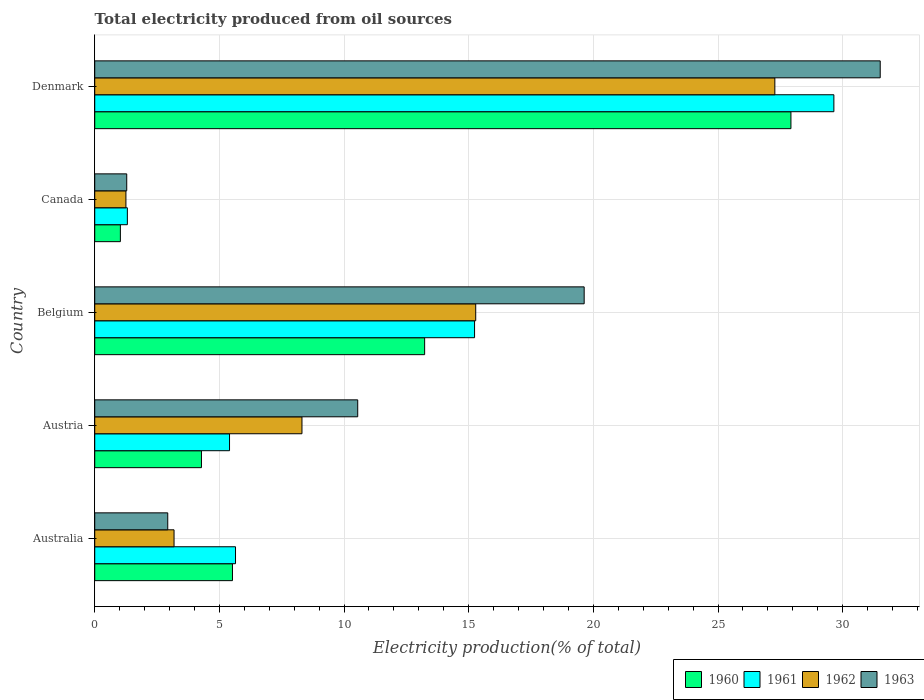How many different coloured bars are there?
Keep it short and to the point. 4. Are the number of bars on each tick of the Y-axis equal?
Provide a short and direct response. Yes. How many bars are there on the 3rd tick from the bottom?
Make the answer very short. 4. In how many cases, is the number of bars for a given country not equal to the number of legend labels?
Give a very brief answer. 0. What is the total electricity produced in 1961 in Canada?
Offer a very short reply. 1.31. Across all countries, what is the maximum total electricity produced in 1960?
Keep it short and to the point. 27.92. Across all countries, what is the minimum total electricity produced in 1962?
Provide a succinct answer. 1.25. What is the total total electricity produced in 1961 in the graph?
Offer a terse response. 57.24. What is the difference between the total electricity produced in 1963 in Canada and that in Denmark?
Offer a very short reply. -30.22. What is the difference between the total electricity produced in 1960 in Austria and the total electricity produced in 1963 in Belgium?
Offer a very short reply. -15.35. What is the average total electricity produced in 1961 per country?
Ensure brevity in your answer.  11.45. What is the difference between the total electricity produced in 1962 and total electricity produced in 1963 in Denmark?
Offer a very short reply. -4.23. In how many countries, is the total electricity produced in 1963 greater than 11 %?
Provide a short and direct response. 2. What is the ratio of the total electricity produced in 1961 in Belgium to that in Denmark?
Offer a terse response. 0.51. Is the total electricity produced in 1961 in Belgium less than that in Canada?
Provide a short and direct response. No. What is the difference between the highest and the second highest total electricity produced in 1960?
Your response must be concise. 14.69. What is the difference between the highest and the lowest total electricity produced in 1961?
Give a very brief answer. 28.34. Is it the case that in every country, the sum of the total electricity produced in 1963 and total electricity produced in 1961 is greater than the sum of total electricity produced in 1962 and total electricity produced in 1960?
Make the answer very short. No. What does the 2nd bar from the top in Canada represents?
Keep it short and to the point. 1962. Are all the bars in the graph horizontal?
Ensure brevity in your answer.  Yes. Does the graph contain any zero values?
Offer a very short reply. No. What is the title of the graph?
Give a very brief answer. Total electricity produced from oil sources. Does "2006" appear as one of the legend labels in the graph?
Your answer should be compact. No. What is the label or title of the X-axis?
Keep it short and to the point. Electricity production(% of total). What is the label or title of the Y-axis?
Offer a very short reply. Country. What is the Electricity production(% of total) of 1960 in Australia?
Your answer should be very brief. 5.52. What is the Electricity production(% of total) in 1961 in Australia?
Provide a short and direct response. 5.65. What is the Electricity production(% of total) in 1962 in Australia?
Your answer should be very brief. 3.18. What is the Electricity production(% of total) in 1963 in Australia?
Your answer should be very brief. 2.93. What is the Electricity production(% of total) in 1960 in Austria?
Offer a very short reply. 4.28. What is the Electricity production(% of total) of 1961 in Austria?
Your response must be concise. 5.41. What is the Electricity production(% of total) of 1962 in Austria?
Your answer should be compact. 8.31. What is the Electricity production(% of total) in 1963 in Austria?
Give a very brief answer. 10.55. What is the Electricity production(% of total) of 1960 in Belgium?
Keep it short and to the point. 13.23. What is the Electricity production(% of total) in 1961 in Belgium?
Your answer should be compact. 15.23. What is the Electricity production(% of total) of 1962 in Belgium?
Provide a succinct answer. 15.28. What is the Electricity production(% of total) of 1963 in Belgium?
Make the answer very short. 19.63. What is the Electricity production(% of total) in 1960 in Canada?
Offer a very short reply. 1.03. What is the Electricity production(% of total) of 1961 in Canada?
Your answer should be compact. 1.31. What is the Electricity production(% of total) of 1962 in Canada?
Make the answer very short. 1.25. What is the Electricity production(% of total) in 1963 in Canada?
Your response must be concise. 1.28. What is the Electricity production(% of total) in 1960 in Denmark?
Provide a succinct answer. 27.92. What is the Electricity production(% of total) in 1961 in Denmark?
Your answer should be very brief. 29.65. What is the Electricity production(% of total) of 1962 in Denmark?
Provide a short and direct response. 27.28. What is the Electricity production(% of total) of 1963 in Denmark?
Your response must be concise. 31.51. Across all countries, what is the maximum Electricity production(% of total) in 1960?
Keep it short and to the point. 27.92. Across all countries, what is the maximum Electricity production(% of total) in 1961?
Provide a succinct answer. 29.65. Across all countries, what is the maximum Electricity production(% of total) of 1962?
Offer a terse response. 27.28. Across all countries, what is the maximum Electricity production(% of total) in 1963?
Provide a short and direct response. 31.51. Across all countries, what is the minimum Electricity production(% of total) of 1960?
Your answer should be compact. 1.03. Across all countries, what is the minimum Electricity production(% of total) of 1961?
Your response must be concise. 1.31. Across all countries, what is the minimum Electricity production(% of total) of 1962?
Your answer should be compact. 1.25. Across all countries, what is the minimum Electricity production(% of total) in 1963?
Make the answer very short. 1.28. What is the total Electricity production(% of total) in 1960 in the graph?
Give a very brief answer. 51.99. What is the total Electricity production(% of total) of 1961 in the graph?
Provide a succinct answer. 57.24. What is the total Electricity production(% of total) of 1962 in the graph?
Your answer should be compact. 55.3. What is the total Electricity production(% of total) of 1963 in the graph?
Keep it short and to the point. 65.9. What is the difference between the Electricity production(% of total) in 1960 in Australia and that in Austria?
Ensure brevity in your answer.  1.24. What is the difference between the Electricity production(% of total) in 1961 in Australia and that in Austria?
Ensure brevity in your answer.  0.24. What is the difference between the Electricity production(% of total) in 1962 in Australia and that in Austria?
Give a very brief answer. -5.13. What is the difference between the Electricity production(% of total) in 1963 in Australia and that in Austria?
Keep it short and to the point. -7.62. What is the difference between the Electricity production(% of total) of 1960 in Australia and that in Belgium?
Your answer should be very brief. -7.71. What is the difference between the Electricity production(% of total) in 1961 in Australia and that in Belgium?
Provide a succinct answer. -9.59. What is the difference between the Electricity production(% of total) in 1962 in Australia and that in Belgium?
Ensure brevity in your answer.  -12.1. What is the difference between the Electricity production(% of total) of 1963 in Australia and that in Belgium?
Offer a very short reply. -16.7. What is the difference between the Electricity production(% of total) of 1960 in Australia and that in Canada?
Your answer should be very brief. 4.5. What is the difference between the Electricity production(% of total) in 1961 in Australia and that in Canada?
Your answer should be compact. 4.34. What is the difference between the Electricity production(% of total) of 1962 in Australia and that in Canada?
Provide a short and direct response. 1.93. What is the difference between the Electricity production(% of total) in 1963 in Australia and that in Canada?
Give a very brief answer. 1.64. What is the difference between the Electricity production(% of total) of 1960 in Australia and that in Denmark?
Your answer should be compact. -22.4. What is the difference between the Electricity production(% of total) in 1961 in Australia and that in Denmark?
Provide a succinct answer. -24. What is the difference between the Electricity production(% of total) of 1962 in Australia and that in Denmark?
Provide a short and direct response. -24.1. What is the difference between the Electricity production(% of total) of 1963 in Australia and that in Denmark?
Provide a short and direct response. -28.58. What is the difference between the Electricity production(% of total) of 1960 in Austria and that in Belgium?
Ensure brevity in your answer.  -8.95. What is the difference between the Electricity production(% of total) in 1961 in Austria and that in Belgium?
Keep it short and to the point. -9.83. What is the difference between the Electricity production(% of total) of 1962 in Austria and that in Belgium?
Give a very brief answer. -6.97. What is the difference between the Electricity production(% of total) in 1963 in Austria and that in Belgium?
Make the answer very short. -9.08. What is the difference between the Electricity production(% of total) in 1960 in Austria and that in Canada?
Provide a short and direct response. 3.25. What is the difference between the Electricity production(% of total) of 1961 in Austria and that in Canada?
Offer a terse response. 4.1. What is the difference between the Electricity production(% of total) of 1962 in Austria and that in Canada?
Provide a short and direct response. 7.06. What is the difference between the Electricity production(% of total) of 1963 in Austria and that in Canada?
Your response must be concise. 9.26. What is the difference between the Electricity production(% of total) in 1960 in Austria and that in Denmark?
Provide a succinct answer. -23.64. What is the difference between the Electricity production(% of total) in 1961 in Austria and that in Denmark?
Keep it short and to the point. -24.24. What is the difference between the Electricity production(% of total) of 1962 in Austria and that in Denmark?
Your answer should be very brief. -18.97. What is the difference between the Electricity production(% of total) in 1963 in Austria and that in Denmark?
Keep it short and to the point. -20.96. What is the difference between the Electricity production(% of total) in 1960 in Belgium and that in Canada?
Ensure brevity in your answer.  12.2. What is the difference between the Electricity production(% of total) in 1961 in Belgium and that in Canada?
Make the answer very short. 13.93. What is the difference between the Electricity production(% of total) in 1962 in Belgium and that in Canada?
Make the answer very short. 14.03. What is the difference between the Electricity production(% of total) in 1963 in Belgium and that in Canada?
Ensure brevity in your answer.  18.35. What is the difference between the Electricity production(% of total) of 1960 in Belgium and that in Denmark?
Ensure brevity in your answer.  -14.69. What is the difference between the Electricity production(% of total) in 1961 in Belgium and that in Denmark?
Provide a succinct answer. -14.41. What is the difference between the Electricity production(% of total) of 1962 in Belgium and that in Denmark?
Give a very brief answer. -12. What is the difference between the Electricity production(% of total) of 1963 in Belgium and that in Denmark?
Your answer should be very brief. -11.87. What is the difference between the Electricity production(% of total) in 1960 in Canada and that in Denmark?
Provide a short and direct response. -26.9. What is the difference between the Electricity production(% of total) in 1961 in Canada and that in Denmark?
Keep it short and to the point. -28.34. What is the difference between the Electricity production(% of total) of 1962 in Canada and that in Denmark?
Ensure brevity in your answer.  -26.03. What is the difference between the Electricity production(% of total) of 1963 in Canada and that in Denmark?
Your response must be concise. -30.22. What is the difference between the Electricity production(% of total) of 1960 in Australia and the Electricity production(% of total) of 1961 in Austria?
Offer a terse response. 0.12. What is the difference between the Electricity production(% of total) of 1960 in Australia and the Electricity production(% of total) of 1962 in Austria?
Provide a short and direct response. -2.79. What is the difference between the Electricity production(% of total) in 1960 in Australia and the Electricity production(% of total) in 1963 in Austria?
Give a very brief answer. -5.02. What is the difference between the Electricity production(% of total) in 1961 in Australia and the Electricity production(% of total) in 1962 in Austria?
Make the answer very short. -2.67. What is the difference between the Electricity production(% of total) in 1961 in Australia and the Electricity production(% of total) in 1963 in Austria?
Give a very brief answer. -4.9. What is the difference between the Electricity production(% of total) of 1962 in Australia and the Electricity production(% of total) of 1963 in Austria?
Ensure brevity in your answer.  -7.37. What is the difference between the Electricity production(% of total) of 1960 in Australia and the Electricity production(% of total) of 1961 in Belgium?
Make the answer very short. -9.71. What is the difference between the Electricity production(% of total) of 1960 in Australia and the Electricity production(% of total) of 1962 in Belgium?
Provide a short and direct response. -9.76. What is the difference between the Electricity production(% of total) of 1960 in Australia and the Electricity production(% of total) of 1963 in Belgium?
Make the answer very short. -14.11. What is the difference between the Electricity production(% of total) in 1961 in Australia and the Electricity production(% of total) in 1962 in Belgium?
Offer a terse response. -9.63. What is the difference between the Electricity production(% of total) in 1961 in Australia and the Electricity production(% of total) in 1963 in Belgium?
Your response must be concise. -13.98. What is the difference between the Electricity production(% of total) of 1962 in Australia and the Electricity production(% of total) of 1963 in Belgium?
Your response must be concise. -16.45. What is the difference between the Electricity production(% of total) in 1960 in Australia and the Electricity production(% of total) in 1961 in Canada?
Keep it short and to the point. 4.22. What is the difference between the Electricity production(% of total) of 1960 in Australia and the Electricity production(% of total) of 1962 in Canada?
Offer a very short reply. 4.27. What is the difference between the Electricity production(% of total) of 1960 in Australia and the Electricity production(% of total) of 1963 in Canada?
Offer a very short reply. 4.24. What is the difference between the Electricity production(% of total) in 1961 in Australia and the Electricity production(% of total) in 1962 in Canada?
Your response must be concise. 4.4. What is the difference between the Electricity production(% of total) in 1961 in Australia and the Electricity production(% of total) in 1963 in Canada?
Provide a short and direct response. 4.36. What is the difference between the Electricity production(% of total) in 1962 in Australia and the Electricity production(% of total) in 1963 in Canada?
Provide a succinct answer. 1.9. What is the difference between the Electricity production(% of total) of 1960 in Australia and the Electricity production(% of total) of 1961 in Denmark?
Your answer should be compact. -24.12. What is the difference between the Electricity production(% of total) in 1960 in Australia and the Electricity production(% of total) in 1962 in Denmark?
Your response must be concise. -21.75. What is the difference between the Electricity production(% of total) in 1960 in Australia and the Electricity production(% of total) in 1963 in Denmark?
Ensure brevity in your answer.  -25.98. What is the difference between the Electricity production(% of total) of 1961 in Australia and the Electricity production(% of total) of 1962 in Denmark?
Your response must be concise. -21.63. What is the difference between the Electricity production(% of total) of 1961 in Australia and the Electricity production(% of total) of 1963 in Denmark?
Your answer should be compact. -25.86. What is the difference between the Electricity production(% of total) in 1962 in Australia and the Electricity production(% of total) in 1963 in Denmark?
Your response must be concise. -28.32. What is the difference between the Electricity production(% of total) of 1960 in Austria and the Electricity production(% of total) of 1961 in Belgium?
Your answer should be very brief. -10.95. What is the difference between the Electricity production(% of total) of 1960 in Austria and the Electricity production(% of total) of 1962 in Belgium?
Ensure brevity in your answer.  -11. What is the difference between the Electricity production(% of total) in 1960 in Austria and the Electricity production(% of total) in 1963 in Belgium?
Make the answer very short. -15.35. What is the difference between the Electricity production(% of total) in 1961 in Austria and the Electricity production(% of total) in 1962 in Belgium?
Provide a short and direct response. -9.87. What is the difference between the Electricity production(% of total) in 1961 in Austria and the Electricity production(% of total) in 1963 in Belgium?
Your answer should be compact. -14.22. What is the difference between the Electricity production(% of total) in 1962 in Austria and the Electricity production(% of total) in 1963 in Belgium?
Offer a very short reply. -11.32. What is the difference between the Electricity production(% of total) in 1960 in Austria and the Electricity production(% of total) in 1961 in Canada?
Provide a succinct answer. 2.97. What is the difference between the Electricity production(% of total) of 1960 in Austria and the Electricity production(% of total) of 1962 in Canada?
Make the answer very short. 3.03. What is the difference between the Electricity production(% of total) in 1960 in Austria and the Electricity production(% of total) in 1963 in Canada?
Make the answer very short. 3. What is the difference between the Electricity production(% of total) of 1961 in Austria and the Electricity production(% of total) of 1962 in Canada?
Offer a terse response. 4.16. What is the difference between the Electricity production(% of total) of 1961 in Austria and the Electricity production(% of total) of 1963 in Canada?
Keep it short and to the point. 4.12. What is the difference between the Electricity production(% of total) in 1962 in Austria and the Electricity production(% of total) in 1963 in Canada?
Keep it short and to the point. 7.03. What is the difference between the Electricity production(% of total) in 1960 in Austria and the Electricity production(% of total) in 1961 in Denmark?
Your answer should be very brief. -25.37. What is the difference between the Electricity production(% of total) in 1960 in Austria and the Electricity production(% of total) in 1962 in Denmark?
Offer a very short reply. -23. What is the difference between the Electricity production(% of total) in 1960 in Austria and the Electricity production(% of total) in 1963 in Denmark?
Provide a succinct answer. -27.22. What is the difference between the Electricity production(% of total) in 1961 in Austria and the Electricity production(% of total) in 1962 in Denmark?
Keep it short and to the point. -21.87. What is the difference between the Electricity production(% of total) in 1961 in Austria and the Electricity production(% of total) in 1963 in Denmark?
Give a very brief answer. -26.1. What is the difference between the Electricity production(% of total) in 1962 in Austria and the Electricity production(% of total) in 1963 in Denmark?
Make the answer very short. -23.19. What is the difference between the Electricity production(% of total) of 1960 in Belgium and the Electricity production(% of total) of 1961 in Canada?
Offer a very short reply. 11.92. What is the difference between the Electricity production(% of total) in 1960 in Belgium and the Electricity production(% of total) in 1962 in Canada?
Offer a terse response. 11.98. What is the difference between the Electricity production(% of total) of 1960 in Belgium and the Electricity production(% of total) of 1963 in Canada?
Your response must be concise. 11.95. What is the difference between the Electricity production(% of total) of 1961 in Belgium and the Electricity production(% of total) of 1962 in Canada?
Ensure brevity in your answer.  13.98. What is the difference between the Electricity production(% of total) in 1961 in Belgium and the Electricity production(% of total) in 1963 in Canada?
Give a very brief answer. 13.95. What is the difference between the Electricity production(% of total) of 1962 in Belgium and the Electricity production(% of total) of 1963 in Canada?
Offer a very short reply. 14. What is the difference between the Electricity production(% of total) in 1960 in Belgium and the Electricity production(% of total) in 1961 in Denmark?
Provide a succinct answer. -16.41. What is the difference between the Electricity production(% of total) in 1960 in Belgium and the Electricity production(% of total) in 1962 in Denmark?
Provide a succinct answer. -14.05. What is the difference between the Electricity production(% of total) in 1960 in Belgium and the Electricity production(% of total) in 1963 in Denmark?
Keep it short and to the point. -18.27. What is the difference between the Electricity production(% of total) in 1961 in Belgium and the Electricity production(% of total) in 1962 in Denmark?
Offer a very short reply. -12.04. What is the difference between the Electricity production(% of total) of 1961 in Belgium and the Electricity production(% of total) of 1963 in Denmark?
Keep it short and to the point. -16.27. What is the difference between the Electricity production(% of total) in 1962 in Belgium and the Electricity production(% of total) in 1963 in Denmark?
Your answer should be very brief. -16.22. What is the difference between the Electricity production(% of total) in 1960 in Canada and the Electricity production(% of total) in 1961 in Denmark?
Make the answer very short. -28.62. What is the difference between the Electricity production(% of total) in 1960 in Canada and the Electricity production(% of total) in 1962 in Denmark?
Give a very brief answer. -26.25. What is the difference between the Electricity production(% of total) in 1960 in Canada and the Electricity production(% of total) in 1963 in Denmark?
Keep it short and to the point. -30.48. What is the difference between the Electricity production(% of total) of 1961 in Canada and the Electricity production(% of total) of 1962 in Denmark?
Offer a very short reply. -25.97. What is the difference between the Electricity production(% of total) in 1961 in Canada and the Electricity production(% of total) in 1963 in Denmark?
Provide a succinct answer. -30.2. What is the difference between the Electricity production(% of total) of 1962 in Canada and the Electricity production(% of total) of 1963 in Denmark?
Ensure brevity in your answer.  -30.25. What is the average Electricity production(% of total) in 1960 per country?
Provide a short and direct response. 10.4. What is the average Electricity production(% of total) of 1961 per country?
Provide a short and direct response. 11.45. What is the average Electricity production(% of total) in 1962 per country?
Offer a terse response. 11.06. What is the average Electricity production(% of total) in 1963 per country?
Provide a succinct answer. 13.18. What is the difference between the Electricity production(% of total) of 1960 and Electricity production(% of total) of 1961 in Australia?
Ensure brevity in your answer.  -0.12. What is the difference between the Electricity production(% of total) of 1960 and Electricity production(% of total) of 1962 in Australia?
Offer a terse response. 2.34. What is the difference between the Electricity production(% of total) of 1960 and Electricity production(% of total) of 1963 in Australia?
Give a very brief answer. 2.6. What is the difference between the Electricity production(% of total) of 1961 and Electricity production(% of total) of 1962 in Australia?
Provide a short and direct response. 2.47. What is the difference between the Electricity production(% of total) in 1961 and Electricity production(% of total) in 1963 in Australia?
Make the answer very short. 2.72. What is the difference between the Electricity production(% of total) of 1962 and Electricity production(% of total) of 1963 in Australia?
Make the answer very short. 0.25. What is the difference between the Electricity production(% of total) of 1960 and Electricity production(% of total) of 1961 in Austria?
Keep it short and to the point. -1.13. What is the difference between the Electricity production(% of total) of 1960 and Electricity production(% of total) of 1962 in Austria?
Provide a short and direct response. -4.03. What is the difference between the Electricity production(% of total) of 1960 and Electricity production(% of total) of 1963 in Austria?
Provide a short and direct response. -6.27. What is the difference between the Electricity production(% of total) of 1961 and Electricity production(% of total) of 1962 in Austria?
Offer a terse response. -2.91. What is the difference between the Electricity production(% of total) in 1961 and Electricity production(% of total) in 1963 in Austria?
Your answer should be compact. -5.14. What is the difference between the Electricity production(% of total) of 1962 and Electricity production(% of total) of 1963 in Austria?
Your answer should be very brief. -2.24. What is the difference between the Electricity production(% of total) in 1960 and Electricity production(% of total) in 1961 in Belgium?
Your answer should be very brief. -2. What is the difference between the Electricity production(% of total) of 1960 and Electricity production(% of total) of 1962 in Belgium?
Your answer should be very brief. -2.05. What is the difference between the Electricity production(% of total) in 1960 and Electricity production(% of total) in 1963 in Belgium?
Offer a very short reply. -6.4. What is the difference between the Electricity production(% of total) of 1961 and Electricity production(% of total) of 1962 in Belgium?
Provide a short and direct response. -0.05. What is the difference between the Electricity production(% of total) in 1961 and Electricity production(% of total) in 1963 in Belgium?
Ensure brevity in your answer.  -4.4. What is the difference between the Electricity production(% of total) of 1962 and Electricity production(% of total) of 1963 in Belgium?
Ensure brevity in your answer.  -4.35. What is the difference between the Electricity production(% of total) of 1960 and Electricity production(% of total) of 1961 in Canada?
Your answer should be compact. -0.28. What is the difference between the Electricity production(% of total) in 1960 and Electricity production(% of total) in 1962 in Canada?
Your answer should be very brief. -0.22. What is the difference between the Electricity production(% of total) of 1960 and Electricity production(% of total) of 1963 in Canada?
Provide a succinct answer. -0.26. What is the difference between the Electricity production(% of total) in 1961 and Electricity production(% of total) in 1962 in Canada?
Ensure brevity in your answer.  0.06. What is the difference between the Electricity production(% of total) in 1961 and Electricity production(% of total) in 1963 in Canada?
Your answer should be compact. 0.03. What is the difference between the Electricity production(% of total) in 1962 and Electricity production(% of total) in 1963 in Canada?
Provide a succinct answer. -0.03. What is the difference between the Electricity production(% of total) of 1960 and Electricity production(% of total) of 1961 in Denmark?
Make the answer very short. -1.72. What is the difference between the Electricity production(% of total) in 1960 and Electricity production(% of total) in 1962 in Denmark?
Give a very brief answer. 0.65. What is the difference between the Electricity production(% of total) in 1960 and Electricity production(% of total) in 1963 in Denmark?
Your answer should be very brief. -3.58. What is the difference between the Electricity production(% of total) in 1961 and Electricity production(% of total) in 1962 in Denmark?
Your response must be concise. 2.37. What is the difference between the Electricity production(% of total) in 1961 and Electricity production(% of total) in 1963 in Denmark?
Provide a succinct answer. -1.86. What is the difference between the Electricity production(% of total) of 1962 and Electricity production(% of total) of 1963 in Denmark?
Your response must be concise. -4.23. What is the ratio of the Electricity production(% of total) of 1960 in Australia to that in Austria?
Offer a very short reply. 1.29. What is the ratio of the Electricity production(% of total) in 1961 in Australia to that in Austria?
Your response must be concise. 1.04. What is the ratio of the Electricity production(% of total) of 1962 in Australia to that in Austria?
Ensure brevity in your answer.  0.38. What is the ratio of the Electricity production(% of total) of 1963 in Australia to that in Austria?
Your answer should be compact. 0.28. What is the ratio of the Electricity production(% of total) in 1960 in Australia to that in Belgium?
Keep it short and to the point. 0.42. What is the ratio of the Electricity production(% of total) in 1961 in Australia to that in Belgium?
Your answer should be compact. 0.37. What is the ratio of the Electricity production(% of total) in 1962 in Australia to that in Belgium?
Your response must be concise. 0.21. What is the ratio of the Electricity production(% of total) of 1963 in Australia to that in Belgium?
Provide a succinct answer. 0.15. What is the ratio of the Electricity production(% of total) of 1960 in Australia to that in Canada?
Keep it short and to the point. 5.37. What is the ratio of the Electricity production(% of total) in 1961 in Australia to that in Canada?
Your answer should be compact. 4.31. What is the ratio of the Electricity production(% of total) in 1962 in Australia to that in Canada?
Make the answer very short. 2.54. What is the ratio of the Electricity production(% of total) in 1963 in Australia to that in Canada?
Your response must be concise. 2.28. What is the ratio of the Electricity production(% of total) of 1960 in Australia to that in Denmark?
Your answer should be very brief. 0.2. What is the ratio of the Electricity production(% of total) of 1961 in Australia to that in Denmark?
Offer a very short reply. 0.19. What is the ratio of the Electricity production(% of total) in 1962 in Australia to that in Denmark?
Ensure brevity in your answer.  0.12. What is the ratio of the Electricity production(% of total) in 1963 in Australia to that in Denmark?
Keep it short and to the point. 0.09. What is the ratio of the Electricity production(% of total) in 1960 in Austria to that in Belgium?
Provide a succinct answer. 0.32. What is the ratio of the Electricity production(% of total) of 1961 in Austria to that in Belgium?
Offer a very short reply. 0.35. What is the ratio of the Electricity production(% of total) of 1962 in Austria to that in Belgium?
Provide a short and direct response. 0.54. What is the ratio of the Electricity production(% of total) in 1963 in Austria to that in Belgium?
Make the answer very short. 0.54. What is the ratio of the Electricity production(% of total) of 1960 in Austria to that in Canada?
Give a very brief answer. 4.16. What is the ratio of the Electricity production(% of total) in 1961 in Austria to that in Canada?
Offer a very short reply. 4.13. What is the ratio of the Electricity production(% of total) of 1962 in Austria to that in Canada?
Offer a terse response. 6.64. What is the ratio of the Electricity production(% of total) of 1963 in Austria to that in Canada?
Offer a terse response. 8.22. What is the ratio of the Electricity production(% of total) of 1960 in Austria to that in Denmark?
Keep it short and to the point. 0.15. What is the ratio of the Electricity production(% of total) in 1961 in Austria to that in Denmark?
Provide a succinct answer. 0.18. What is the ratio of the Electricity production(% of total) of 1962 in Austria to that in Denmark?
Keep it short and to the point. 0.3. What is the ratio of the Electricity production(% of total) of 1963 in Austria to that in Denmark?
Ensure brevity in your answer.  0.33. What is the ratio of the Electricity production(% of total) of 1960 in Belgium to that in Canada?
Provide a succinct answer. 12.86. What is the ratio of the Electricity production(% of total) of 1961 in Belgium to that in Canada?
Give a very brief answer. 11.64. What is the ratio of the Electricity production(% of total) of 1962 in Belgium to that in Canada?
Your response must be concise. 12.21. What is the ratio of the Electricity production(% of total) of 1963 in Belgium to that in Canada?
Provide a succinct answer. 15.29. What is the ratio of the Electricity production(% of total) of 1960 in Belgium to that in Denmark?
Give a very brief answer. 0.47. What is the ratio of the Electricity production(% of total) in 1961 in Belgium to that in Denmark?
Ensure brevity in your answer.  0.51. What is the ratio of the Electricity production(% of total) in 1962 in Belgium to that in Denmark?
Your answer should be very brief. 0.56. What is the ratio of the Electricity production(% of total) in 1963 in Belgium to that in Denmark?
Give a very brief answer. 0.62. What is the ratio of the Electricity production(% of total) in 1960 in Canada to that in Denmark?
Your answer should be compact. 0.04. What is the ratio of the Electricity production(% of total) of 1961 in Canada to that in Denmark?
Make the answer very short. 0.04. What is the ratio of the Electricity production(% of total) of 1962 in Canada to that in Denmark?
Offer a very short reply. 0.05. What is the ratio of the Electricity production(% of total) of 1963 in Canada to that in Denmark?
Provide a short and direct response. 0.04. What is the difference between the highest and the second highest Electricity production(% of total) of 1960?
Offer a very short reply. 14.69. What is the difference between the highest and the second highest Electricity production(% of total) of 1961?
Ensure brevity in your answer.  14.41. What is the difference between the highest and the second highest Electricity production(% of total) in 1962?
Offer a terse response. 12. What is the difference between the highest and the second highest Electricity production(% of total) of 1963?
Your answer should be very brief. 11.87. What is the difference between the highest and the lowest Electricity production(% of total) of 1960?
Your response must be concise. 26.9. What is the difference between the highest and the lowest Electricity production(% of total) in 1961?
Provide a short and direct response. 28.34. What is the difference between the highest and the lowest Electricity production(% of total) of 1962?
Your response must be concise. 26.03. What is the difference between the highest and the lowest Electricity production(% of total) of 1963?
Give a very brief answer. 30.22. 